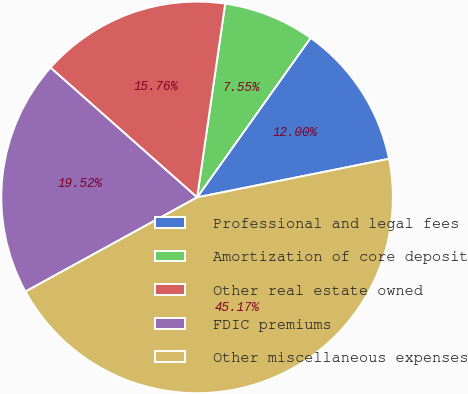<chart> <loc_0><loc_0><loc_500><loc_500><pie_chart><fcel>Professional and legal fees<fcel>Amortization of core deposit<fcel>Other real estate owned<fcel>FDIC premiums<fcel>Other miscellaneous expenses<nl><fcel>12.0%<fcel>7.55%<fcel>15.76%<fcel>19.52%<fcel>45.17%<nl></chart> 